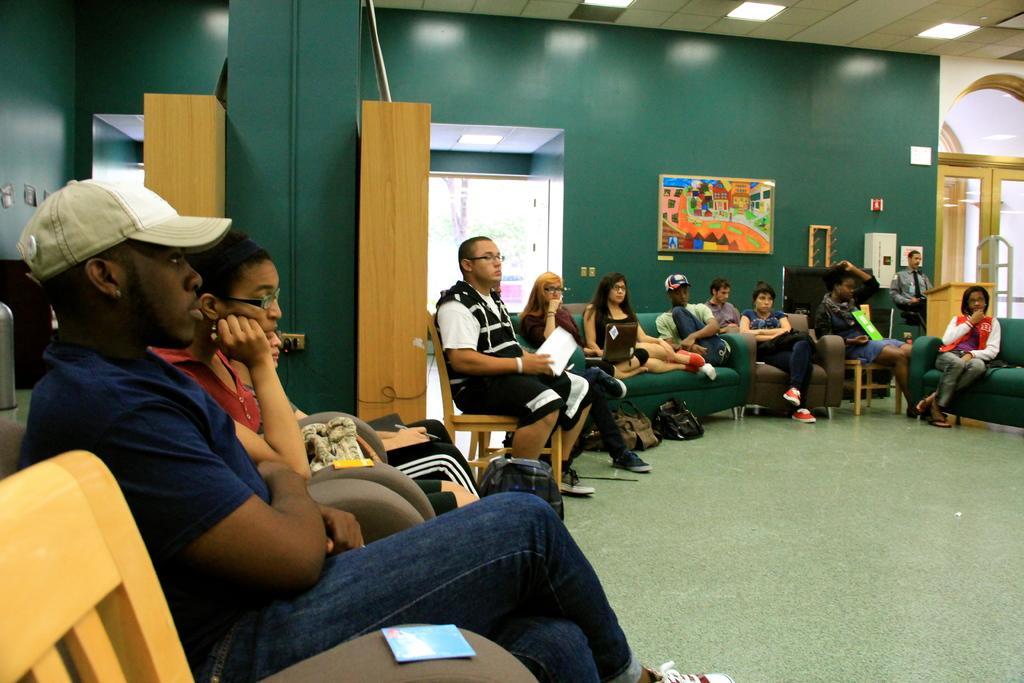In one or two sentences, can you explain what this image depicts? In this picture we can see a group of people on the floor, they are sitting on chairs and sofas, here we can see papers, podium, bags, doors, photo frame, pillars and some objects and in the background we can see a wall, roof, lights. 